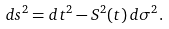Convert formula to latex. <formula><loc_0><loc_0><loc_500><loc_500>d s ^ { 2 } = d t ^ { 2 } - S ^ { 2 } ( t ) \, d \sigma ^ { 2 } .</formula> 